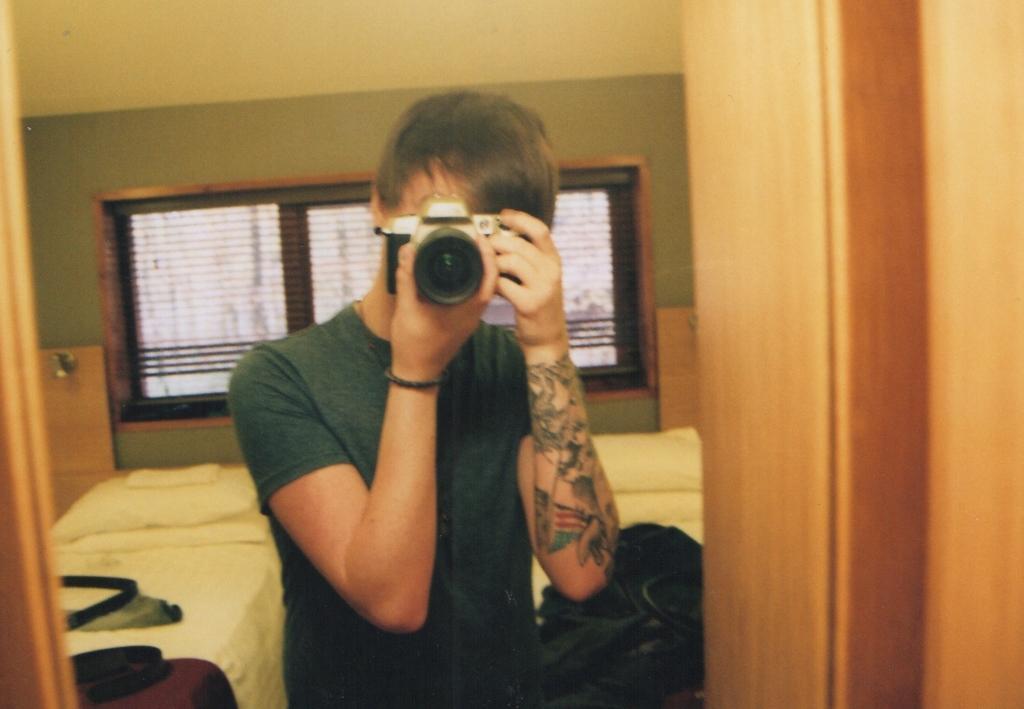Describe this image in one or two sentences. In the image we can see there is a person standing and he is holding camera in his hand. There is tattooed on his hand and behind there are beds. There are pillows on the beds. There is window on the wall. 